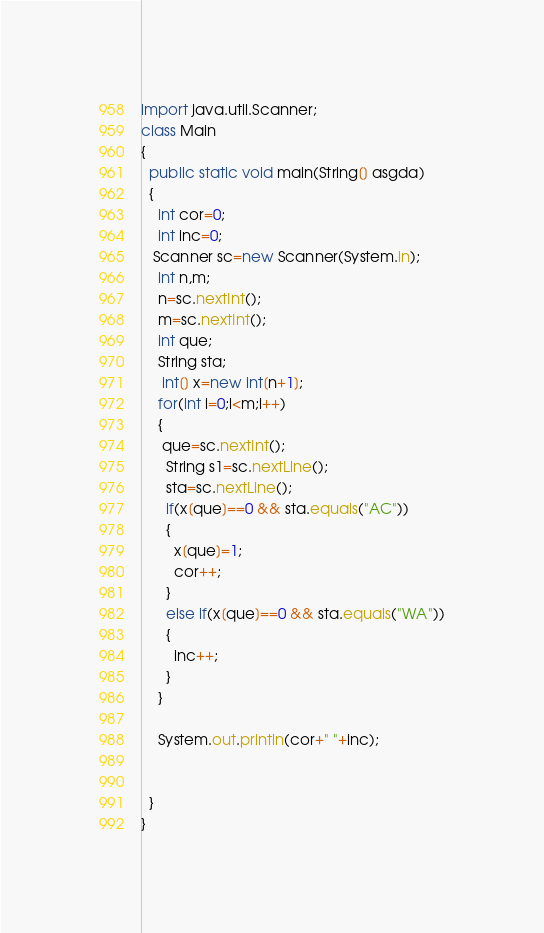Convert code to text. <code><loc_0><loc_0><loc_500><loc_500><_Java_>import java.util.Scanner;
class Main
{
  public static void main(String[] asgda)
  {
    int cor=0;
    int inc=0;
   Scanner sc=new Scanner(System.in);
    int n,m;
    n=sc.nextInt();
    m=sc.nextInt();
    int que;
    String sta;
     int[] x=new int[n+1];
    for(int i=0;i<m;i++)
    {
     que=sc.nextInt();
      String s1=sc.nextLine();
      sta=sc.nextLine();
      if(x[que]==0 && sta.equals("AC"))
      {
        x[que]=1;
        cor++;
      }
      else if(x[que]==0 && sta.equals("WA"))
      {
        inc++;
      }
    }
   
    System.out.println(cor+" "+inc);
   
    
  }
}</code> 